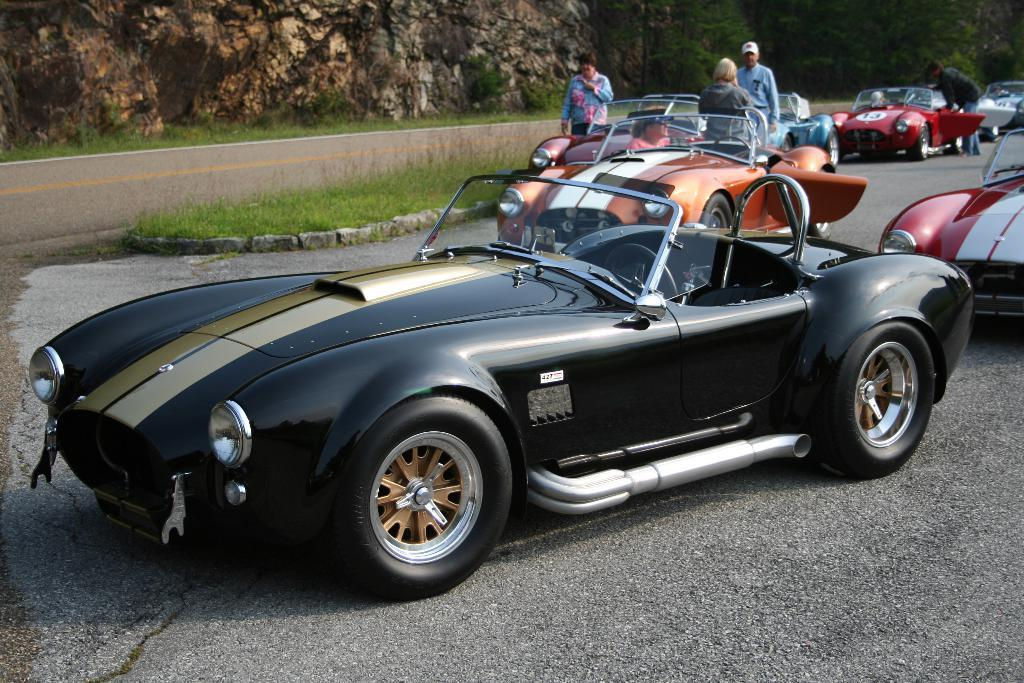What type of vehicles can be seen in the image? There are cars in the image. How many people are present in the image? There are four persons in the image. What is located in the middle of the image? There is grass in the middle of the image. What can be seen in the background of the image? There are trees and a rock in the background of the image. What type of knife is being used by the grandfather in the image? There is no knife or grandfather present in the image. What direction are the persons pointing in the image? There is no indication of anyone pointing in the image. 